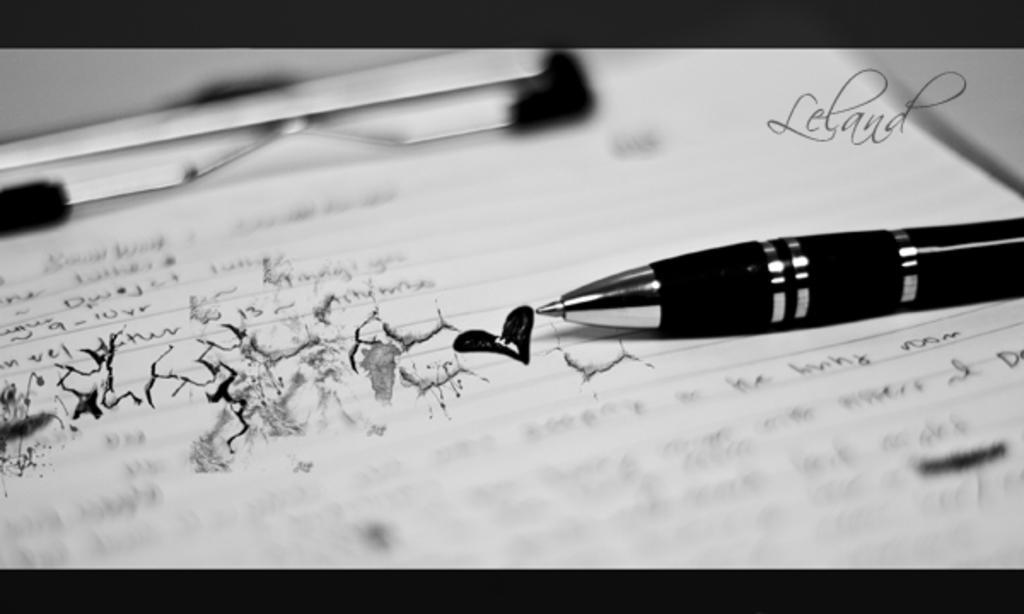Could you give a brief overview of what you see in this image? In this image we can see a paper on the pad. There is a pen on the paper. There is some text written on the paper. 